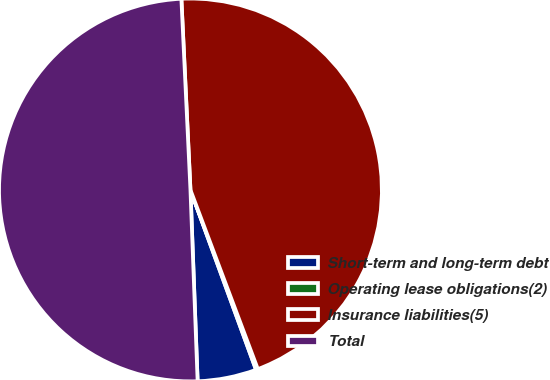<chart> <loc_0><loc_0><loc_500><loc_500><pie_chart><fcel>Short-term and long-term debt<fcel>Operating lease obligations(2)<fcel>Insurance liabilities(5)<fcel>Total<nl><fcel>4.97%<fcel>0.16%<fcel>45.03%<fcel>49.84%<nl></chart> 